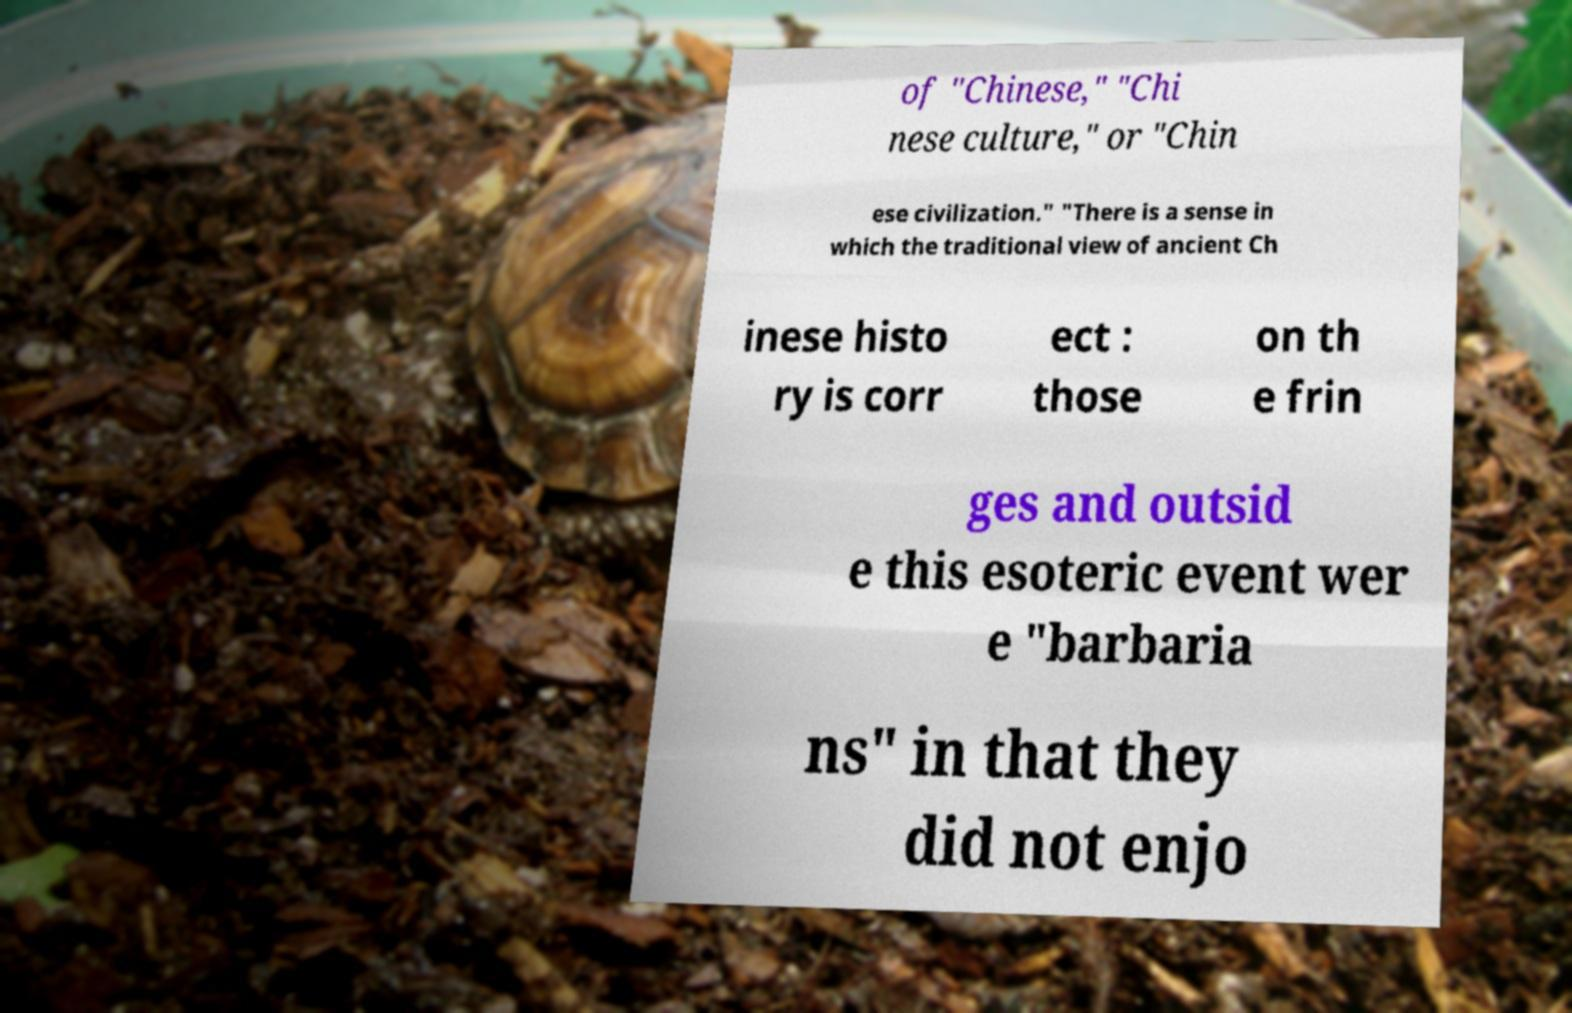There's text embedded in this image that I need extracted. Can you transcribe it verbatim? of "Chinese," "Chi nese culture," or "Chin ese civilization." "There is a sense in which the traditional view of ancient Ch inese histo ry is corr ect : those on th e frin ges and outsid e this esoteric event wer e "barbaria ns" in that they did not enjo 